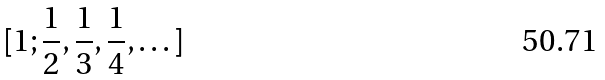<formula> <loc_0><loc_0><loc_500><loc_500>[ 1 ; \frac { 1 } { 2 } , \frac { 1 } { 3 } , \frac { 1 } { 4 } , \dots ]</formula> 